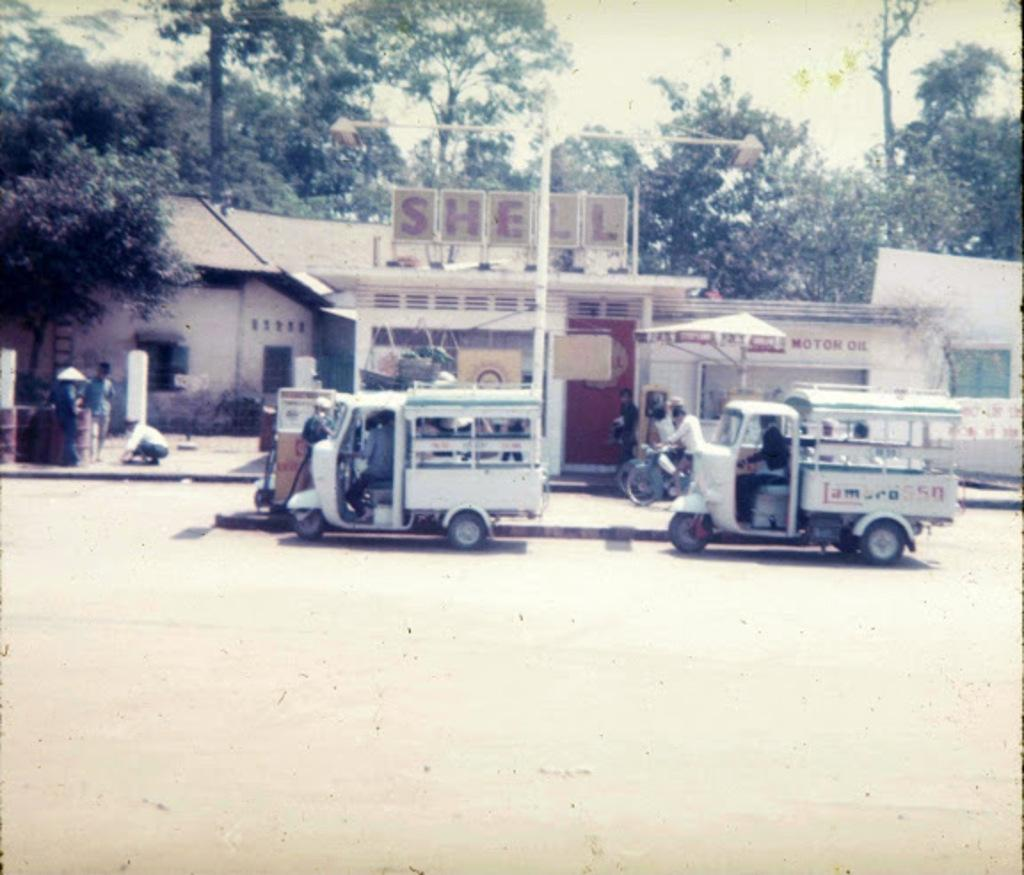How many persons are visible in the image? There are persons in the image, but the exact number is not specified. What are the persons in the vehicles doing? Some of the persons are in vehicles, but their actions are not described. What type of structures can be seen in the image? There are buildings in the image. What other objects are present in the image besides buildings? There are posters and trees in the image. What is the setting of the image? There is a road in the image, suggesting it is an outdoor scene. What is visible in the sky? The sky is visible in the image, but no specific details about the sky are provided. What is the sister of the person in the red car doing in the image? There is no mention of a sister or a red car in the image, so this question cannot be answered. 